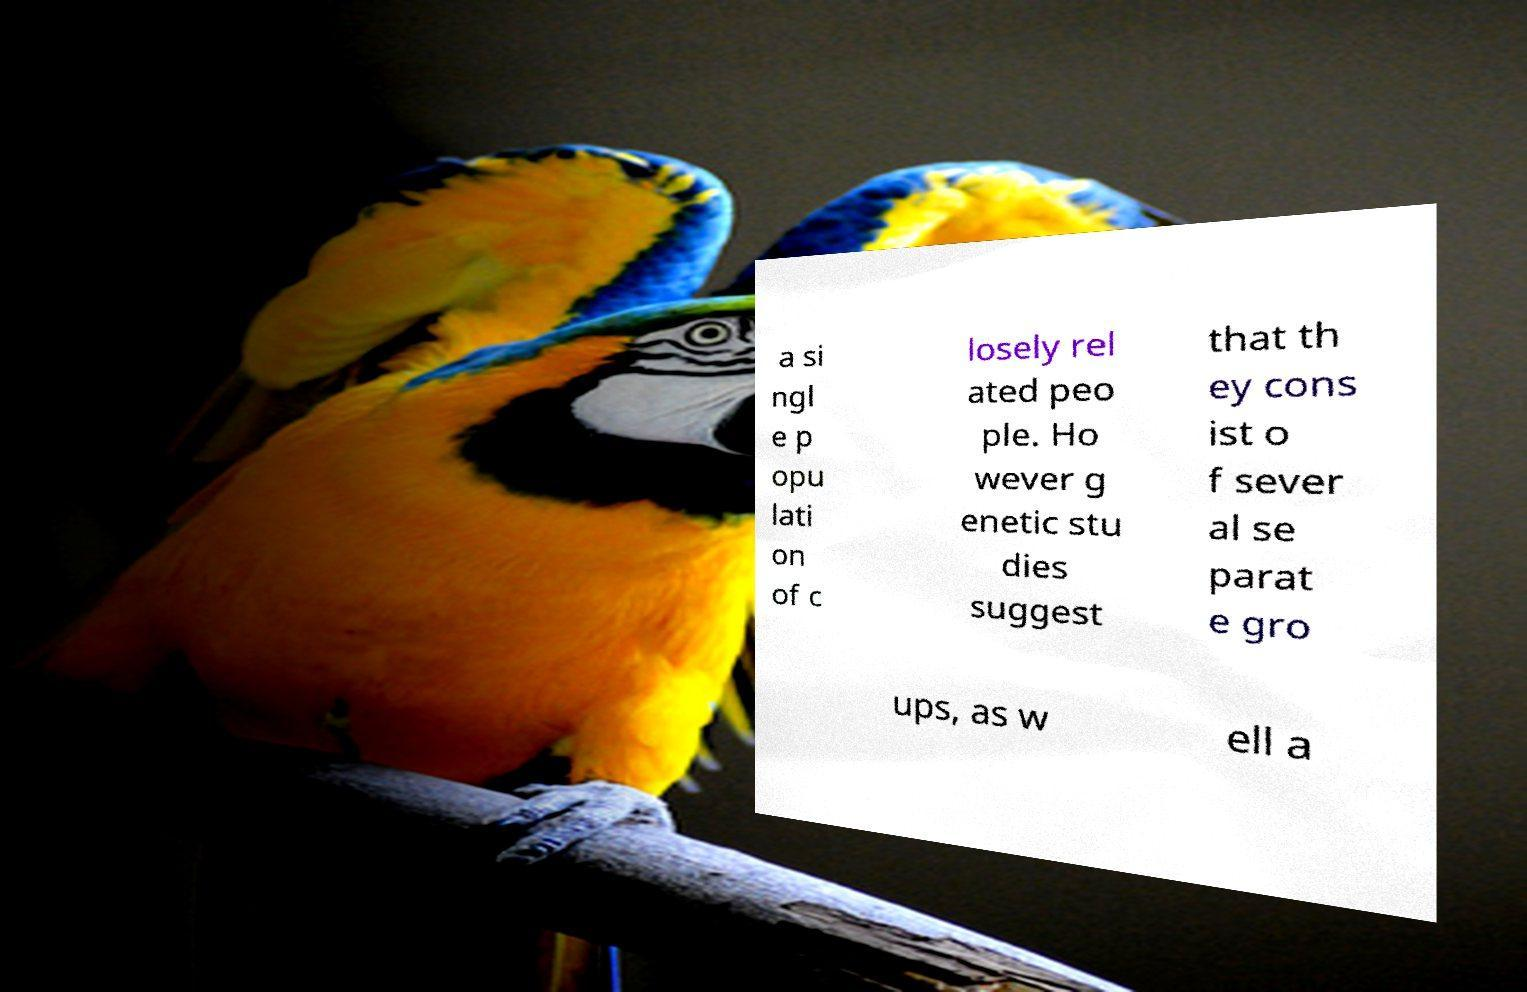Can you accurately transcribe the text from the provided image for me? a si ngl e p opu lati on of c losely rel ated peo ple. Ho wever g enetic stu dies suggest that th ey cons ist o f sever al se parat e gro ups, as w ell a 